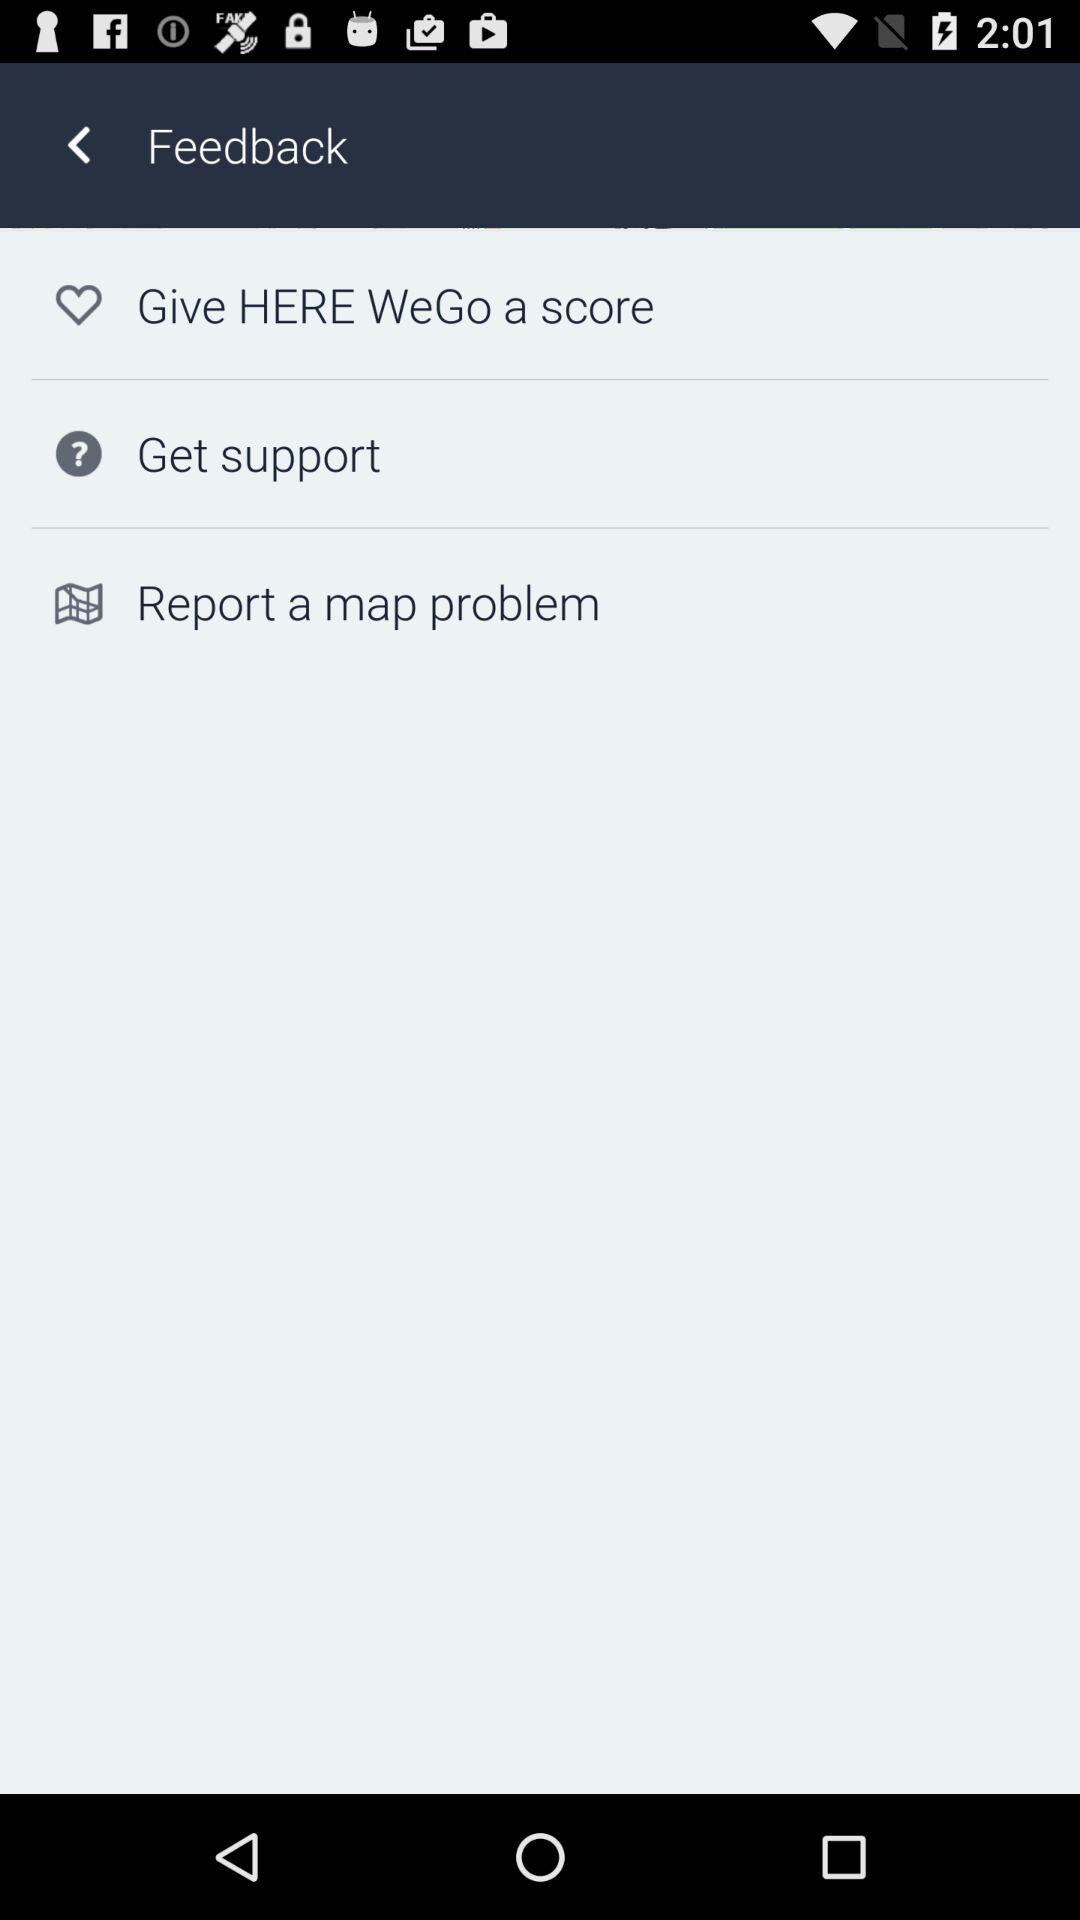How many feedback options are there?
Answer the question using a single word or phrase. 3 